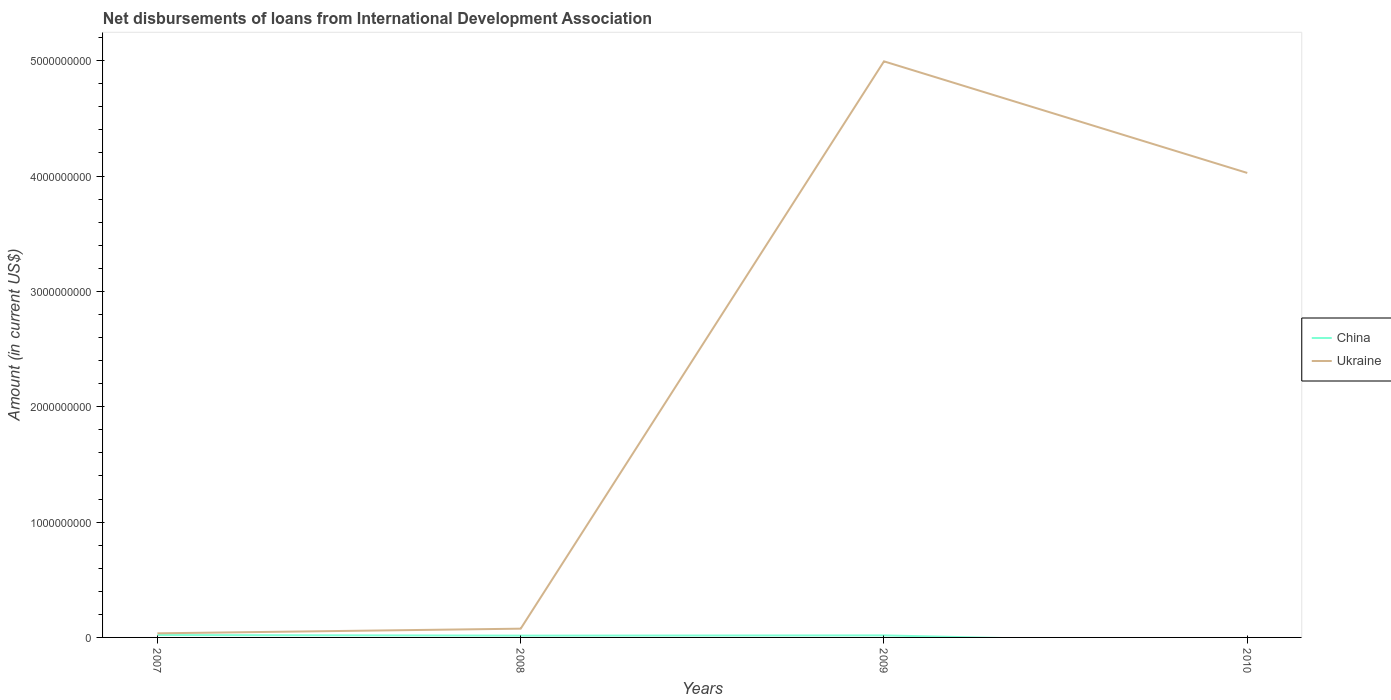Across all years, what is the maximum amount of loans disbursed in Ukraine?
Offer a terse response. 3.56e+07. What is the total amount of loans disbursed in China in the graph?
Your response must be concise. 5.18e+06. What is the difference between the highest and the second highest amount of loans disbursed in Ukraine?
Your answer should be very brief. 4.96e+09. Is the amount of loans disbursed in Ukraine strictly greater than the amount of loans disbursed in China over the years?
Provide a short and direct response. No. Are the values on the major ticks of Y-axis written in scientific E-notation?
Ensure brevity in your answer.  No. Does the graph contain grids?
Provide a succinct answer. No. Where does the legend appear in the graph?
Your response must be concise. Center right. What is the title of the graph?
Keep it short and to the point. Net disbursements of loans from International Development Association. Does "Malaysia" appear as one of the legend labels in the graph?
Your answer should be compact. No. What is the label or title of the X-axis?
Your answer should be compact. Years. What is the label or title of the Y-axis?
Give a very brief answer. Amount (in current US$). What is the Amount (in current US$) of China in 2007?
Your response must be concise. 2.08e+07. What is the Amount (in current US$) in Ukraine in 2007?
Give a very brief answer. 3.56e+07. What is the Amount (in current US$) of China in 2008?
Offer a terse response. 1.57e+07. What is the Amount (in current US$) of Ukraine in 2008?
Make the answer very short. 7.60e+07. What is the Amount (in current US$) of China in 2009?
Keep it short and to the point. 1.77e+07. What is the Amount (in current US$) in Ukraine in 2009?
Provide a succinct answer. 4.99e+09. What is the Amount (in current US$) in China in 2010?
Make the answer very short. 0. What is the Amount (in current US$) of Ukraine in 2010?
Keep it short and to the point. 4.03e+09. Across all years, what is the maximum Amount (in current US$) of China?
Your answer should be very brief. 2.08e+07. Across all years, what is the maximum Amount (in current US$) of Ukraine?
Your answer should be very brief. 4.99e+09. Across all years, what is the minimum Amount (in current US$) of Ukraine?
Offer a terse response. 3.56e+07. What is the total Amount (in current US$) in China in the graph?
Make the answer very short. 5.42e+07. What is the total Amount (in current US$) of Ukraine in the graph?
Keep it short and to the point. 9.13e+09. What is the difference between the Amount (in current US$) of China in 2007 and that in 2008?
Keep it short and to the point. 5.18e+06. What is the difference between the Amount (in current US$) in Ukraine in 2007 and that in 2008?
Your response must be concise. -4.04e+07. What is the difference between the Amount (in current US$) of China in 2007 and that in 2009?
Keep it short and to the point. 3.13e+06. What is the difference between the Amount (in current US$) of Ukraine in 2007 and that in 2009?
Keep it short and to the point. -4.96e+09. What is the difference between the Amount (in current US$) of Ukraine in 2007 and that in 2010?
Your answer should be compact. -3.99e+09. What is the difference between the Amount (in current US$) in China in 2008 and that in 2009?
Provide a short and direct response. -2.04e+06. What is the difference between the Amount (in current US$) of Ukraine in 2008 and that in 2009?
Offer a terse response. -4.92e+09. What is the difference between the Amount (in current US$) of Ukraine in 2008 and that in 2010?
Ensure brevity in your answer.  -3.95e+09. What is the difference between the Amount (in current US$) in Ukraine in 2009 and that in 2010?
Your answer should be very brief. 9.67e+08. What is the difference between the Amount (in current US$) in China in 2007 and the Amount (in current US$) in Ukraine in 2008?
Offer a terse response. -5.51e+07. What is the difference between the Amount (in current US$) in China in 2007 and the Amount (in current US$) in Ukraine in 2009?
Keep it short and to the point. -4.97e+09. What is the difference between the Amount (in current US$) of China in 2007 and the Amount (in current US$) of Ukraine in 2010?
Provide a succinct answer. -4.01e+09. What is the difference between the Amount (in current US$) in China in 2008 and the Amount (in current US$) in Ukraine in 2009?
Offer a very short reply. -4.98e+09. What is the difference between the Amount (in current US$) in China in 2008 and the Amount (in current US$) in Ukraine in 2010?
Give a very brief answer. -4.01e+09. What is the difference between the Amount (in current US$) in China in 2009 and the Amount (in current US$) in Ukraine in 2010?
Your answer should be very brief. -4.01e+09. What is the average Amount (in current US$) of China per year?
Offer a terse response. 1.36e+07. What is the average Amount (in current US$) in Ukraine per year?
Provide a short and direct response. 2.28e+09. In the year 2007, what is the difference between the Amount (in current US$) in China and Amount (in current US$) in Ukraine?
Provide a succinct answer. -1.47e+07. In the year 2008, what is the difference between the Amount (in current US$) in China and Amount (in current US$) in Ukraine?
Provide a succinct answer. -6.03e+07. In the year 2009, what is the difference between the Amount (in current US$) in China and Amount (in current US$) in Ukraine?
Provide a short and direct response. -4.98e+09. What is the ratio of the Amount (in current US$) of China in 2007 to that in 2008?
Your response must be concise. 1.33. What is the ratio of the Amount (in current US$) in Ukraine in 2007 to that in 2008?
Provide a succinct answer. 0.47. What is the ratio of the Amount (in current US$) of China in 2007 to that in 2009?
Your answer should be compact. 1.18. What is the ratio of the Amount (in current US$) in Ukraine in 2007 to that in 2009?
Your response must be concise. 0.01. What is the ratio of the Amount (in current US$) of Ukraine in 2007 to that in 2010?
Your answer should be compact. 0.01. What is the ratio of the Amount (in current US$) in China in 2008 to that in 2009?
Give a very brief answer. 0.88. What is the ratio of the Amount (in current US$) of Ukraine in 2008 to that in 2009?
Provide a short and direct response. 0.02. What is the ratio of the Amount (in current US$) of Ukraine in 2008 to that in 2010?
Provide a succinct answer. 0.02. What is the ratio of the Amount (in current US$) in Ukraine in 2009 to that in 2010?
Provide a short and direct response. 1.24. What is the difference between the highest and the second highest Amount (in current US$) in China?
Keep it short and to the point. 3.13e+06. What is the difference between the highest and the second highest Amount (in current US$) of Ukraine?
Keep it short and to the point. 9.67e+08. What is the difference between the highest and the lowest Amount (in current US$) in China?
Keep it short and to the point. 2.08e+07. What is the difference between the highest and the lowest Amount (in current US$) in Ukraine?
Your answer should be compact. 4.96e+09. 